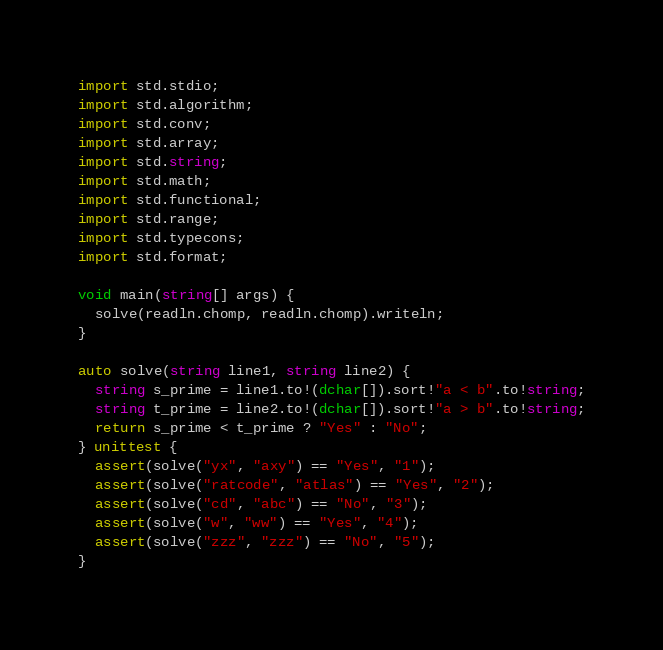Convert code to text. <code><loc_0><loc_0><loc_500><loc_500><_D_>import std.stdio;
import std.algorithm;
import std.conv;
import std.array;
import std.string;
import std.math;
import std.functional;
import std.range;
import std.typecons;
import std.format;

void main(string[] args) {
  solve(readln.chomp, readln.chomp).writeln;
}

auto solve(string line1, string line2) {
  string s_prime = line1.to!(dchar[]).sort!"a < b".to!string;
  string t_prime = line2.to!(dchar[]).sort!"a > b".to!string;
  return s_prime < t_prime ? "Yes" : "No";
} unittest {
  assert(solve("yx", "axy") == "Yes", "1");
  assert(solve("ratcode", "atlas") == "Yes", "2");
  assert(solve("cd", "abc") == "No", "3");
  assert(solve("w", "ww") == "Yes", "4");
  assert(solve("zzz", "zzz") == "No", "5");
}</code> 